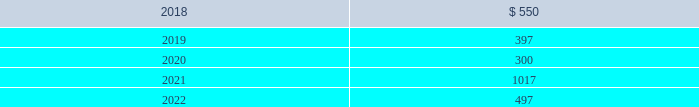In january 2016 , the company issued $ 800 million of debt securities consisting of a $ 400 million aggregate principal three year fixed rate note with a coupon rate of 2.00% ( 2.00 % ) and a $ 400 million aggregate principal seven year fixed rate note with a coupon rate of 3.25% ( 3.25 % ) .
The proceeds were used to repay a portion of the company 2019s outstanding commercial paper , repay the remaining term loan balance , and for general corporate purposes .
The company 2019s public notes and 144a notes may be redeemed by the company at its option at redemption prices that include accrued and unpaid interest and a make-whole premium .
Upon the occurrence of a change of control accompanied by a downgrade of the notes below investment grade rating , within a specified time period , the company would be required to offer to repurchase the public notes and 144a notes at a price equal to 101% ( 101 % ) of the aggregate principal amount thereof , plus any accrued and unpaid interest to the date of repurchase .
The public notes and 144a notes are senior unsecured and unsubordinated obligations of the company and rank equally with all other senior and unsubordinated indebtedness of the company .
The company entered into a registration rights agreement in connection with the issuance of the 144a notes .
Subject to certain limitations set forth in the registration rights agreement , the company has agreed to ( i ) file a registration statement ( the 201cexchange offer registration statement 201d ) with respect to registered offers to exchange the 144a notes for exchange notes ( the 201cexchange notes 201d ) , which will have terms identical in all material respects to the new 10-year notes and new 30-year notes , as applicable , except that the exchange notes will not contain transfer restrictions and will not provide for any increase in the interest rate thereon in certain circumstances and ( ii ) use commercially reasonable efforts to cause the exchange offer registration statement to be declared effective within 270 days after the date of issuance of the 144a notes .
Until such time as the exchange offer registration statement is declared effective , the 144a notes may only be sold in accordance with rule 144a or regulation s of the securities act of 1933 , as amended .
Private notes the company 2019s private notes may be redeemed by the company at its option at redemption prices that include accrued and unpaid interest and a make-whole premium .
Upon the occurrence of specified changes of control involving the company , the company would be required to offer to repurchase the private notes at a price equal to 100% ( 100 % ) of the aggregate principal amount thereof , plus any accrued and unpaid interest to the date of repurchase .
Additionally , the company would be required to make a similar offer to repurchase the private notes upon the occurrence of specified merger events or asset sales involving the company , when accompanied by a downgrade of the private notes below investment grade rating , within a specified time period .
The private notes are unsecured senior obligations of the company and rank equal in right of payment with all other senior indebtedness of the company .
The private notes shall be unconditionally guaranteed by subsidiaries of the company in certain circumstances , as described in the note purchase agreements as amended .
Other debt during 2015 , the company acquired the beneficial interest in the trust owning the leased naperville facility resulting in debt assumption of $ 100.2 million and the addition of $ 135.2 million in property , plant and equipment .
Certain administrative , divisional , and research and development personnel are based at the naperville facility .
Cash paid as a result of the transaction was $ 19.8 million .
The assumption of debt and the majority of the property , plant and equipment addition represented non-cash financing and investing activities , respectively .
The remaining balance on the assumed debt was settled in december 2017 and was reflected in the "other" line of the table above at december 31 , 2016 .
Covenants and future maturities the company is in compliance with all covenants under the company 2019s outstanding indebtedness at december 31 , 2017 .
As of december 31 , 2017 , the aggregate annual maturities of long-term debt for the next five years were : ( millions ) .

What is the total yearly interest expense related to the notes issued in january 2016? 
Computations: ((400 * 2.00%) + (400 * 3.25%))
Answer: 21.0. 